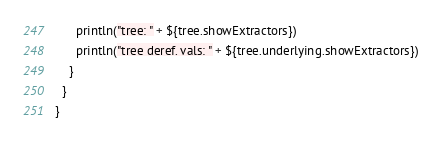Convert code to text. <code><loc_0><loc_0><loc_500><loc_500><_Scala_>      println("tree: " + ${tree.showExtractors})
      println("tree deref. vals: " + ${tree.underlying.showExtractors})
    }
  }
}
</code> 